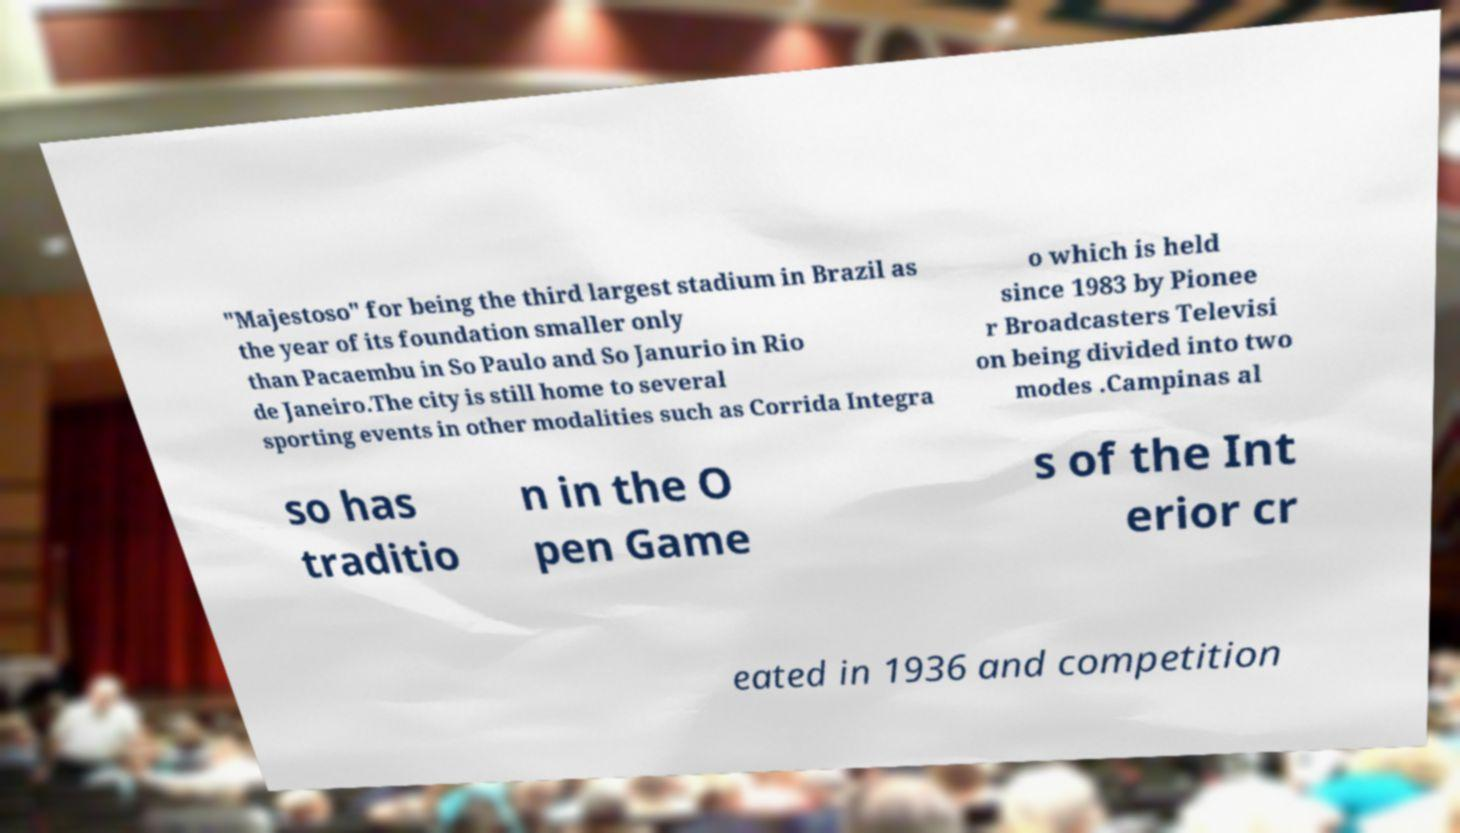For documentation purposes, I need the text within this image transcribed. Could you provide that? "Majestoso" for being the third largest stadium in Brazil as the year of its foundation smaller only than Pacaembu in So Paulo and So Janurio in Rio de Janeiro.The city is still home to several sporting events in other modalities such as Corrida Integra o which is held since 1983 by Pionee r Broadcasters Televisi on being divided into two modes .Campinas al so has traditio n in the O pen Game s of the Int erior cr eated in 1936 and competition 